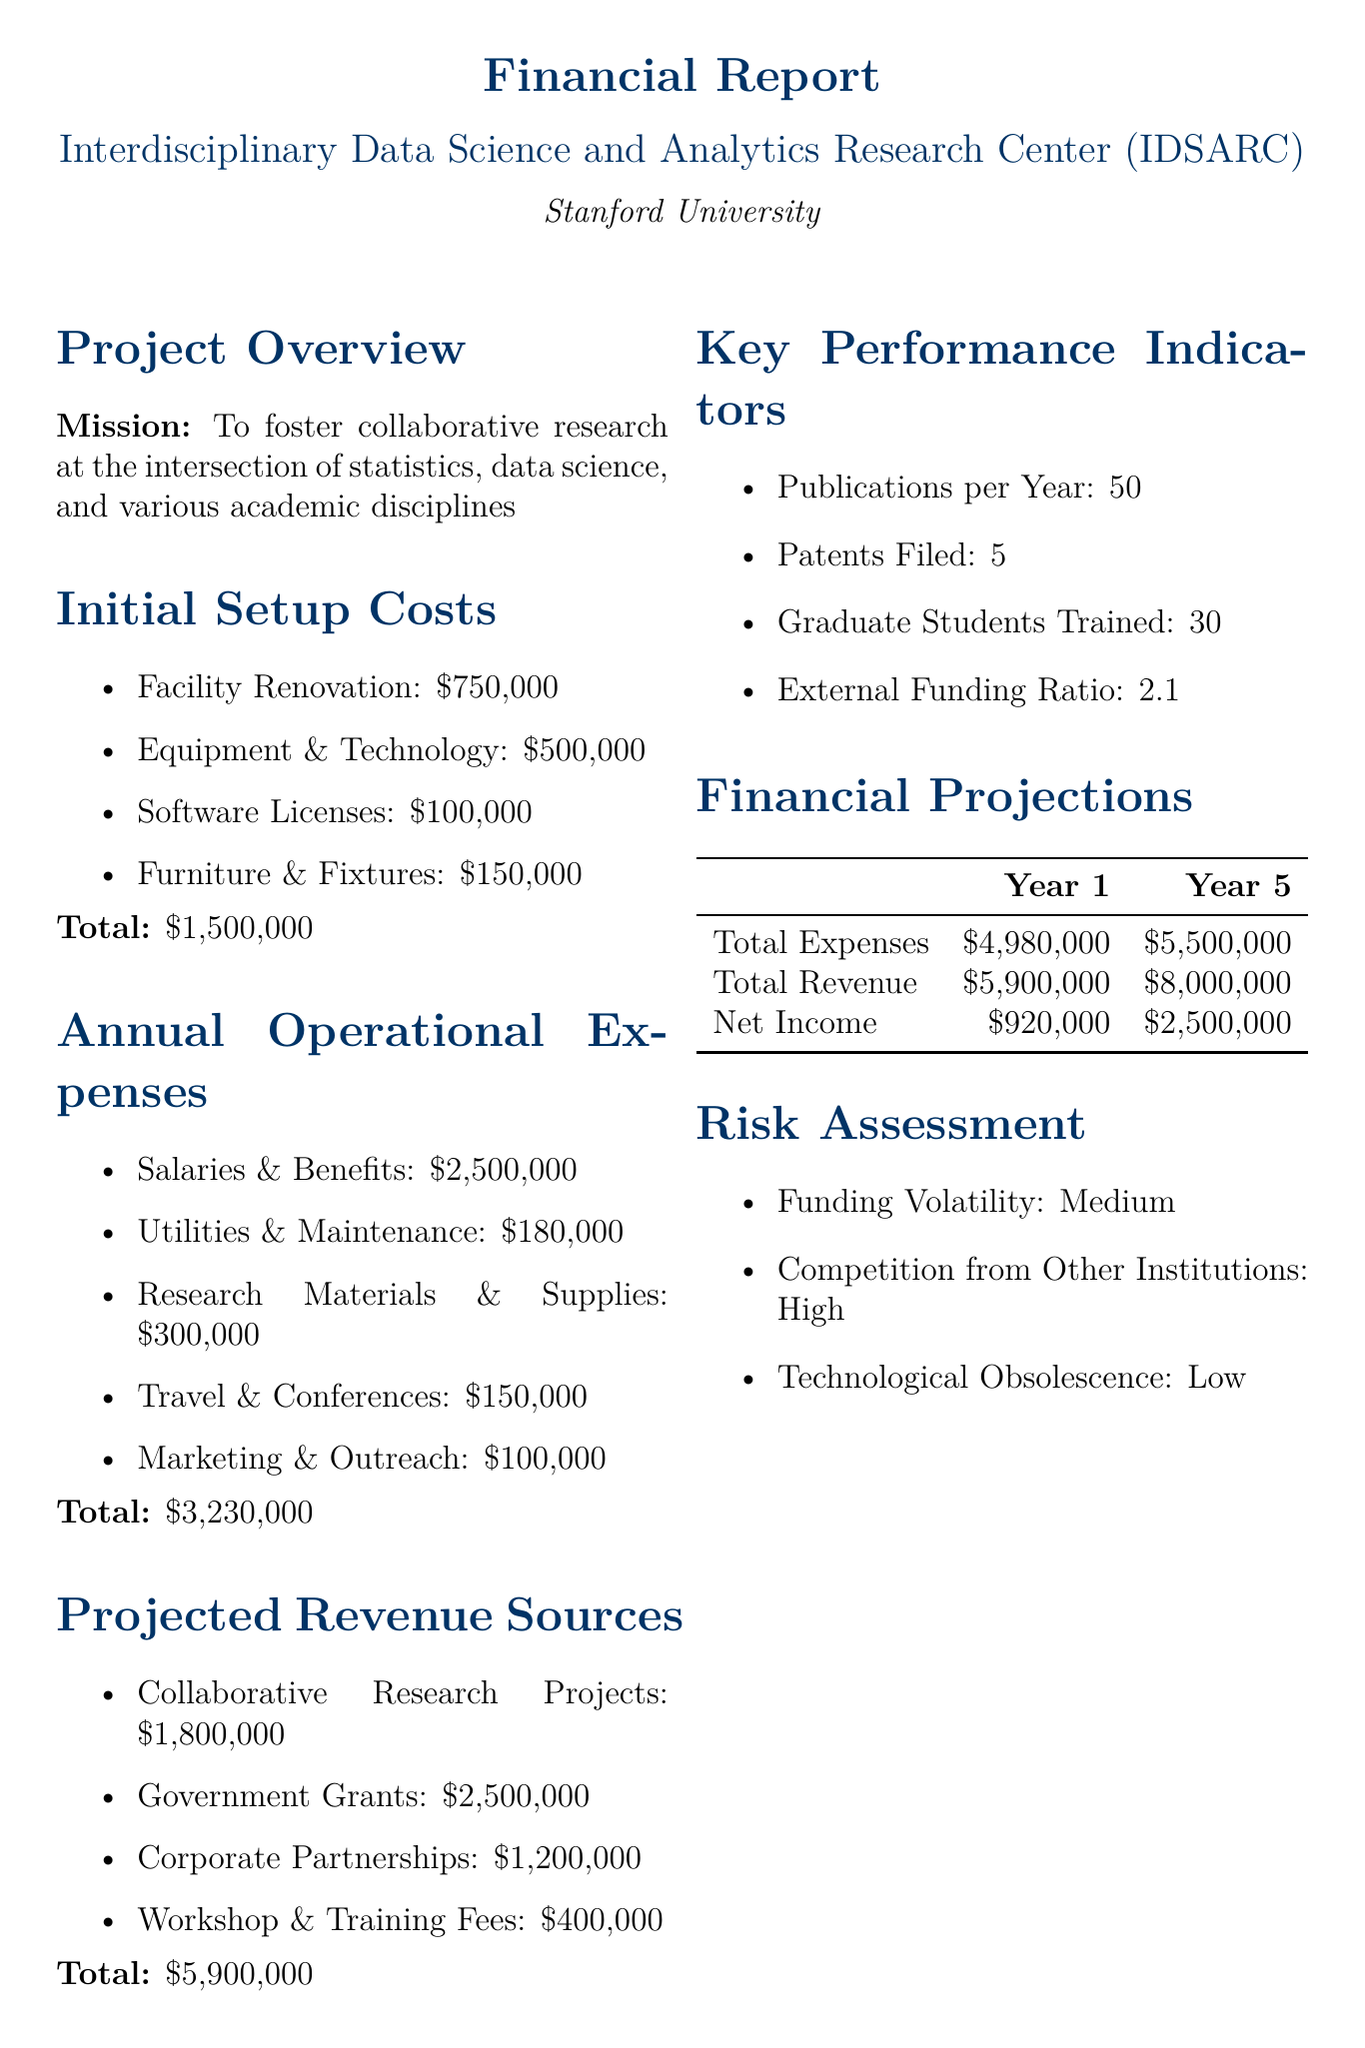What is the total setup cost? The total setup cost is the sum of facility renovation, equipment and technology, software licenses, and furniture and fixtures, which is $750,000 + $500,000 + $100,000 + $150,000 = $1,500,000.
Answer: $1,500,000 What are the annual salaries and benefits? The document lists the annual salaries and benefits as part of the operational expenses, which is $2,500,000.
Answer: $2,500,000 How much is projected revenue from corporate partnerships? The projected revenue from corporate partnerships is specified in the revenue sources as $1,200,000.
Answer: $1,200,000 What is the net income in Year 1? The net income in Year 1 is calculated as the total revenue minus total expenses, which is $5,900,000 - $4,980,000 = $920,000.
Answer: $920,000 How many publications are expected per year? The expected number of publications per year is stated as 50 in the key performance indicators section.
Answer: 50 What is the external funding ratio? The external funding ratio is mentioned in the key performance indicators as 2.1.
Answer: 2.1 What type of risk is described as "Medium"? Funding volatility is described as "Medium" in the risk assessment section.
Answer: Medium What year has the highest projected revenue? The document highlights the projected revenue for Year 5 as $8,000,000, which is the highest compared to Year 1.
Answer: Year 5 What is the total amount allocated for travel and conferences? The total amount for travel and conferences is listed as part of the annual operational expenses, which is $150,000.
Answer: $150,000 